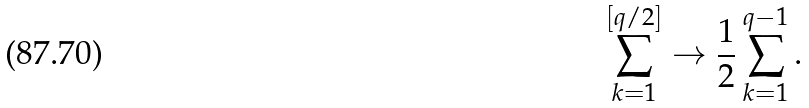<formula> <loc_0><loc_0><loc_500><loc_500>\sum _ { k = 1 } ^ { [ q / 2 ] } \rightarrow \frac { 1 } { 2 } \sum _ { k = 1 } ^ { q - 1 } .</formula> 